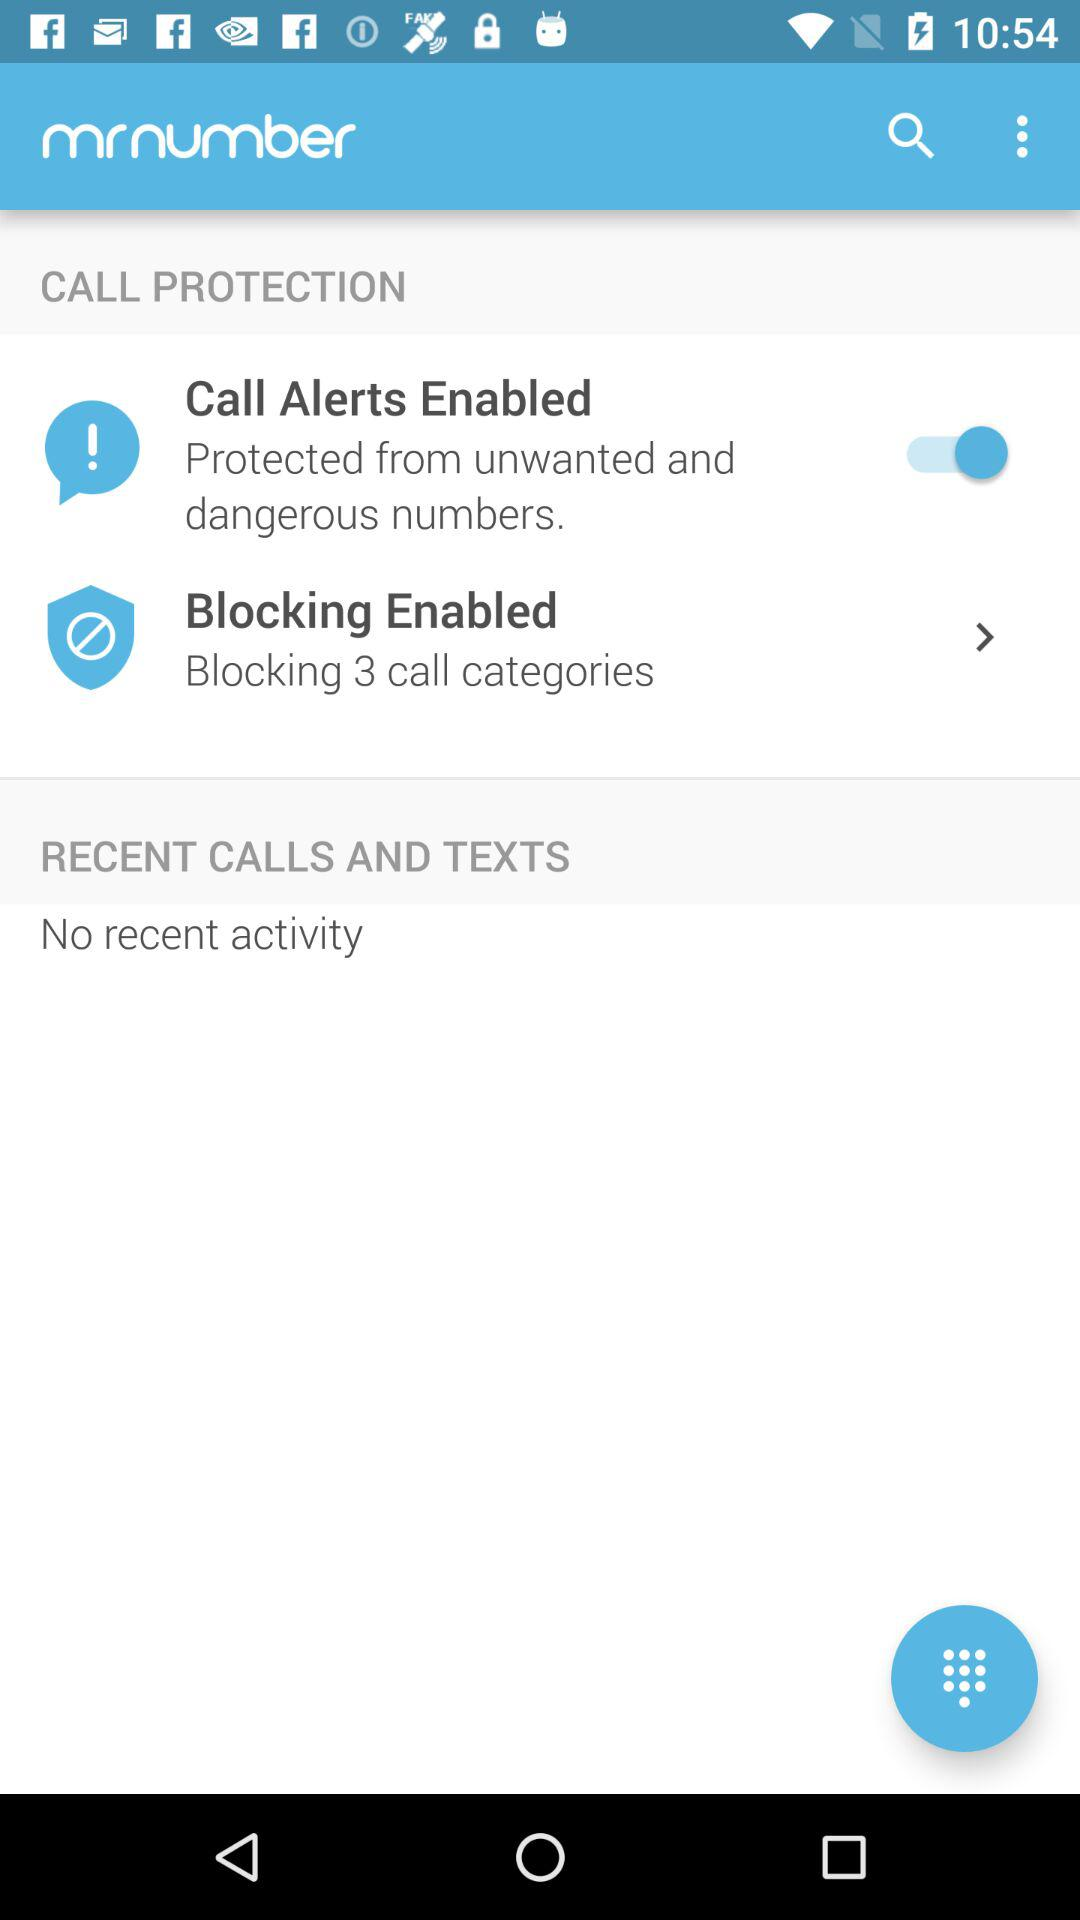What is the status of the "Call Alerts Enabled" under call protection? The status is "on". 